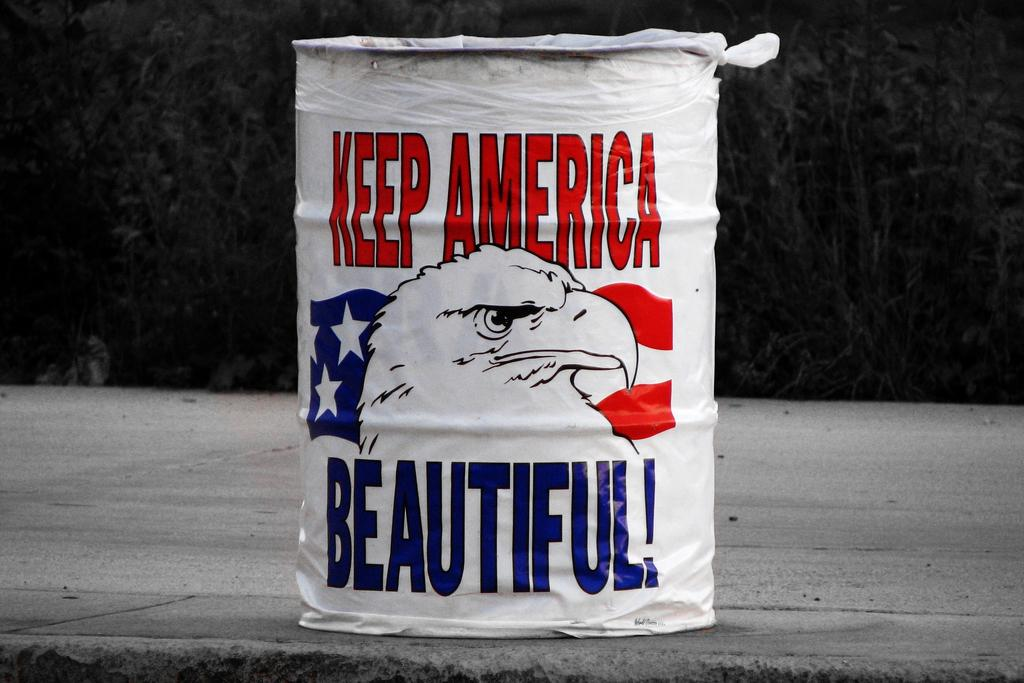<image>
Give a short and clear explanation of the subsequent image. A paint can says "keep america beautiful" on it 